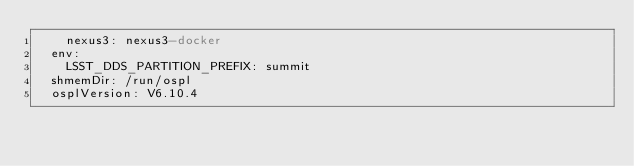<code> <loc_0><loc_0><loc_500><loc_500><_YAML_>    nexus3: nexus3-docker
  env:
    LSST_DDS_PARTITION_PREFIX: summit
  shmemDir: /run/ospl
  osplVersion: V6.10.4
</code> 